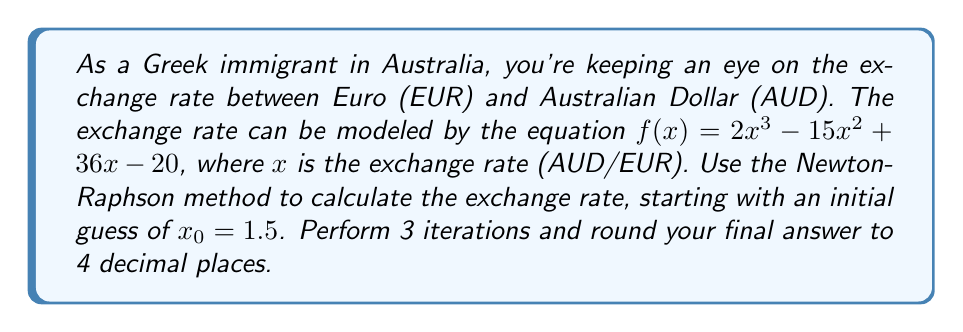Can you answer this question? The Newton-Raphson method is given by the formula:

$$x_{n+1} = x_n - \frac{f(x_n)}{f'(x_n)}$$

Where $f'(x) = 6x^2 - 30x + 36$

Step 1: First iteration
$x_0 = 1.5$
$f(1.5) = 2(1.5)^3 - 15(1.5)^2 + 36(1.5) - 20 = -2.375$
$f'(1.5) = 6(1.5)^2 - 30(1.5) + 36 = 4.5$

$$x_1 = 1.5 - \frac{-2.375}{4.5} = 2.0278$$

Step 2: Second iteration
$f(2.0278) = 2(2.0278)^3 - 15(2.0278)^2 + 36(2.0278) - 20 = 0.3385$
$f'(2.0278) = 6(2.0278)^2 - 30(2.0278) + 36 = 1.9998$

$$x_2 = 2.0278 - \frac{0.3385}{1.9998} = 1.8585$$

Step 3: Third iteration
$f(1.8585) = 2(1.8585)^3 - 15(1.8585)^2 + 36(1.8585) - 20 = -0.0022$
$f'(1.8585) = 6(1.8585)^2 - 30(1.8585) + 36 = 2.8425$

$$x_3 = 1.8585 - \frac{-0.0022}{2.8425} = 1.8593$$

Rounding to 4 decimal places: 1.8593
Answer: 1.8593 AUD/EUR 